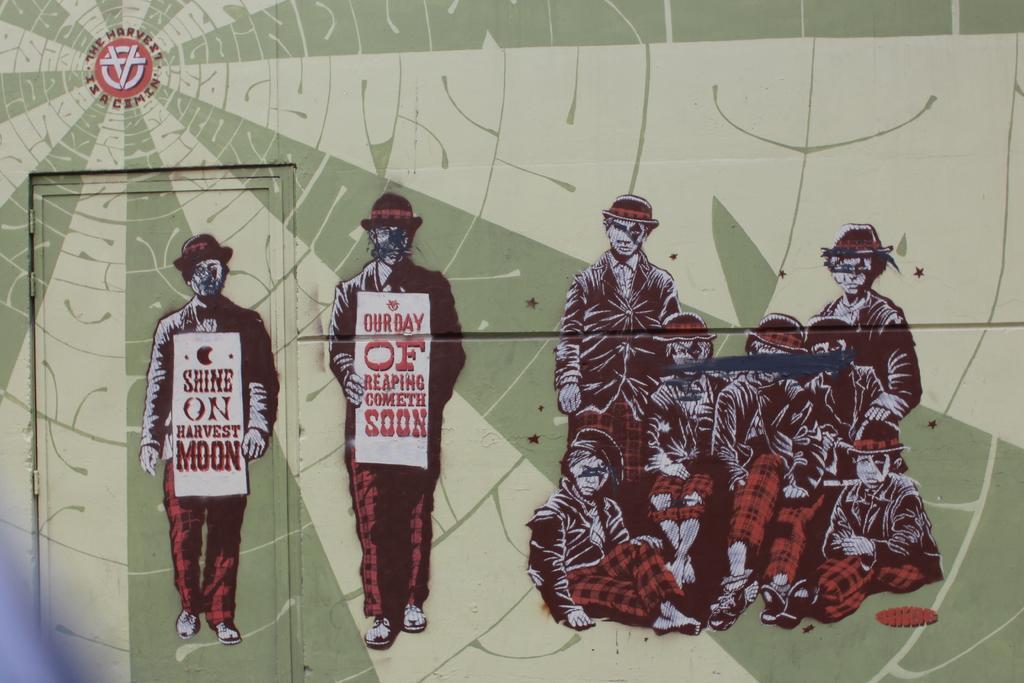Describe this image in one or two sentences. In this image there is a wall on which there is painting. On the left side there are group of people who are sitting on the floor. On the left side there are two persons who are holding the placards. There is a door on the left side. 